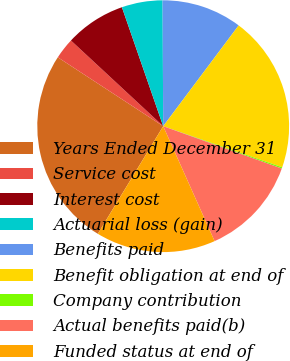<chart> <loc_0><loc_0><loc_500><loc_500><pie_chart><fcel>Years Ended December 31<fcel>Service cost<fcel>Interest cost<fcel>Actuarial loss (gain)<fcel>Benefits paid<fcel>Benefit obligation at end of<fcel>Company contribution<fcel>Actual benefits paid(b)<fcel>Funded status at end of<nl><fcel>25.53%<fcel>2.7%<fcel>7.77%<fcel>5.24%<fcel>10.31%<fcel>20.06%<fcel>0.17%<fcel>12.85%<fcel>15.38%<nl></chart> 